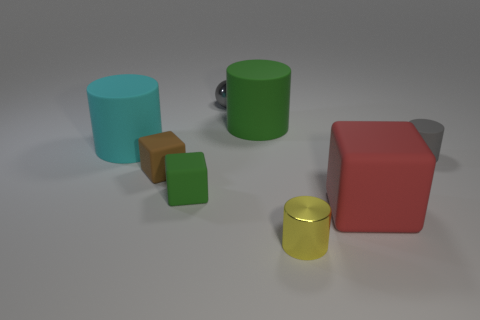Is the color of the tiny shiny object that is behind the yellow shiny cylinder the same as the big block?
Provide a short and direct response. No. Does the big cylinder that is behind the large cyan matte cylinder have the same color as the shiny thing behind the brown rubber object?
Provide a short and direct response. No. Are there any blue cubes that have the same material as the big green cylinder?
Ensure brevity in your answer.  No. What number of gray things are metal blocks or matte blocks?
Offer a terse response. 0. Is the number of big red rubber objects that are right of the gray cylinder greater than the number of small metal things?
Offer a very short reply. No. Is the size of the cyan rubber thing the same as the brown rubber block?
Your answer should be very brief. No. The small cylinder that is the same material as the red thing is what color?
Your answer should be very brief. Gray. There is a matte thing that is the same color as the metallic ball; what shape is it?
Ensure brevity in your answer.  Cylinder. Are there the same number of gray matte cylinders on the left side of the tiny green cube and tiny brown rubber blocks that are in front of the tiny metallic cylinder?
Provide a succinct answer. Yes. What is the shape of the big thing that is in front of the green matte thing that is left of the sphere?
Keep it short and to the point. Cube. 